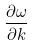Convert formula to latex. <formula><loc_0><loc_0><loc_500><loc_500>\frac { \partial \omega } { \partial k }</formula> 